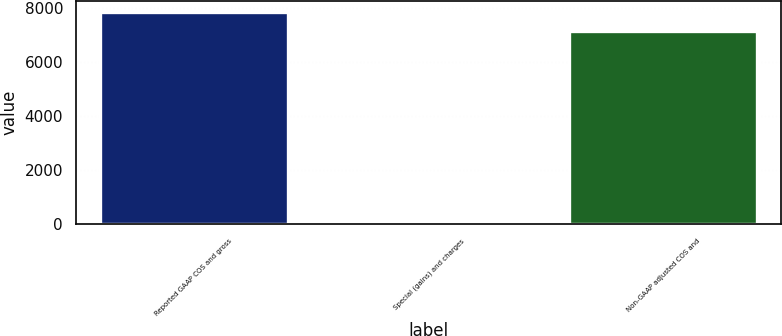<chart> <loc_0><loc_0><loc_500><loc_500><bar_chart><fcel>Reported GAAP COS and gross<fcel>Special (gains) and charges<fcel>Non-GAAP adjusted COS and<nl><fcel>7857.19<fcel>80.6<fcel>7142.9<nl></chart> 